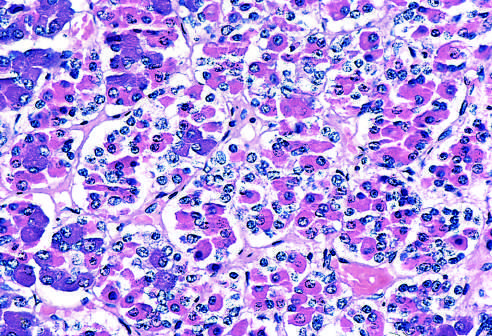what is the normal anterior pituitary gland populated by?
Answer the question using a single word or phrase. Several distinct cell types that express different peptide hormones 